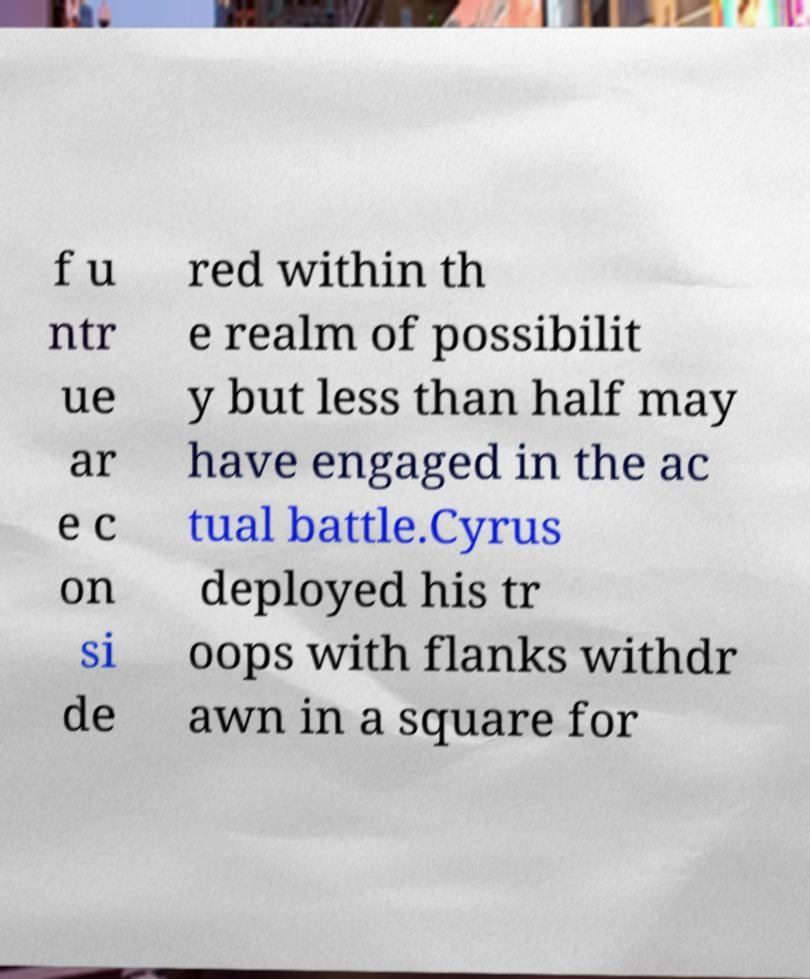Please identify and transcribe the text found in this image. f u ntr ue ar e c on si de red within th e realm of possibilit y but less than half may have engaged in the ac tual battle.Cyrus deployed his tr oops with flanks withdr awn in a square for 